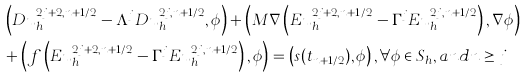Convert formula to latex. <formula><loc_0><loc_0><loc_500><loc_500>& \left ( D u ^ { 2 j + 2 , n + 1 / 2 } _ { h } - \Lambda ^ { j } D u ^ { 2 j , n + 1 / 2 } _ { h } , \phi \right ) + \left ( M \nabla \left ( E { u } ^ { 2 j + 2 , n + 1 / 2 } _ { h } - \Gamma ^ { j } E { u } ^ { 2 j , n + 1 / 2 } _ { h } \right ) , \nabla \phi \right ) \\ & + \left ( f \left ( E { u } ^ { 2 j + 2 , n + 1 / 2 } _ { h } - \Gamma ^ { j } E { u } ^ { 2 j , n + 1 / 2 } _ { h } \right ) , \phi \right ) = \left ( s ( t _ { n + 1 / 2 } ) , \phi \right ) , \forall \phi \in S _ { h } , a n d n \geq j</formula> 